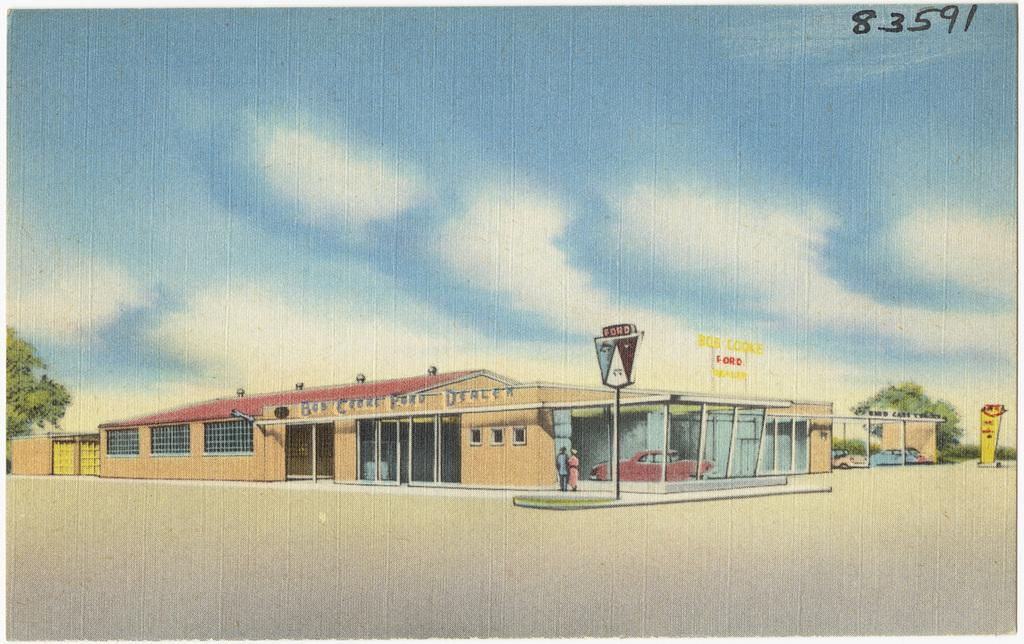<image>
Give a short and clear explanation of the subsequent image. A Ford dealership is shown with the number 83591 in the corner. 